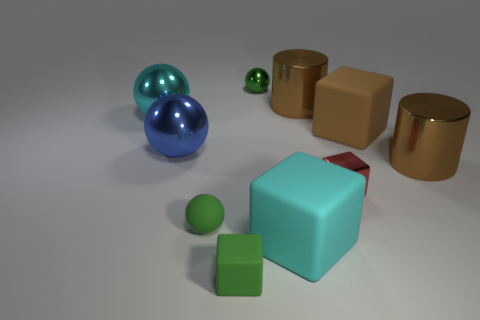Subtract 2 balls. How many balls are left? 2 Subtract all spheres. How many objects are left? 6 Subtract all metal blocks. Subtract all small green metallic objects. How many objects are left? 8 Add 9 green rubber cubes. How many green rubber cubes are left? 10 Add 7 tiny green metallic objects. How many tiny green metallic objects exist? 8 Subtract 0 purple balls. How many objects are left? 10 